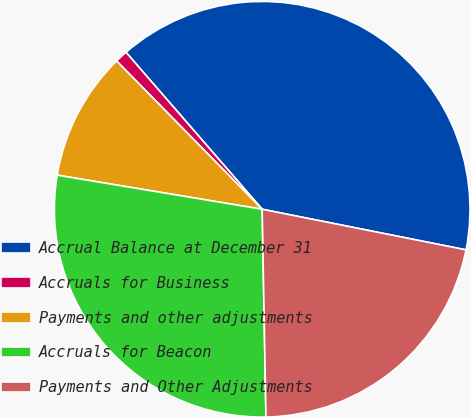Convert chart to OTSL. <chart><loc_0><loc_0><loc_500><loc_500><pie_chart><fcel>Accrual Balance at December 31<fcel>Accruals for Business<fcel>Payments and other adjustments<fcel>Accruals for Beacon<fcel>Payments and Other Adjustments<nl><fcel>39.5%<fcel>0.98%<fcel>10.02%<fcel>27.91%<fcel>21.58%<nl></chart> 